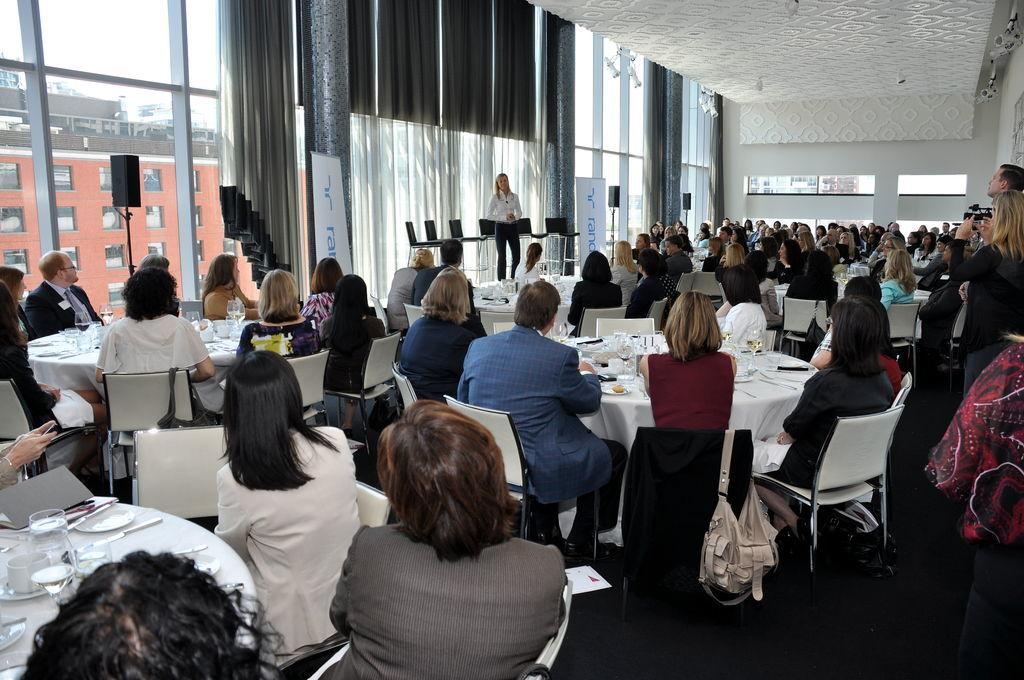What are the people in the image doing? There is a group of people sitting on chairs in the image. Who is standing in front of the group? There is a person standing in front of the group. What can be seen in the background or surrounding area? There is a building visible in the background or surrounding area. What type of object is made of glass in the image? There is a glass object in the image. What type of window treatment is present in the image? There are curtains visible in the image. How many cherries are hanging from the sail in the image? There are no cherries or sails present in the image. Is there a cobweb visible on the glass object in the image? There is no mention of a cobweb in the image, and the presence of a cobweb cannot be confirmed based on the provided facts. 